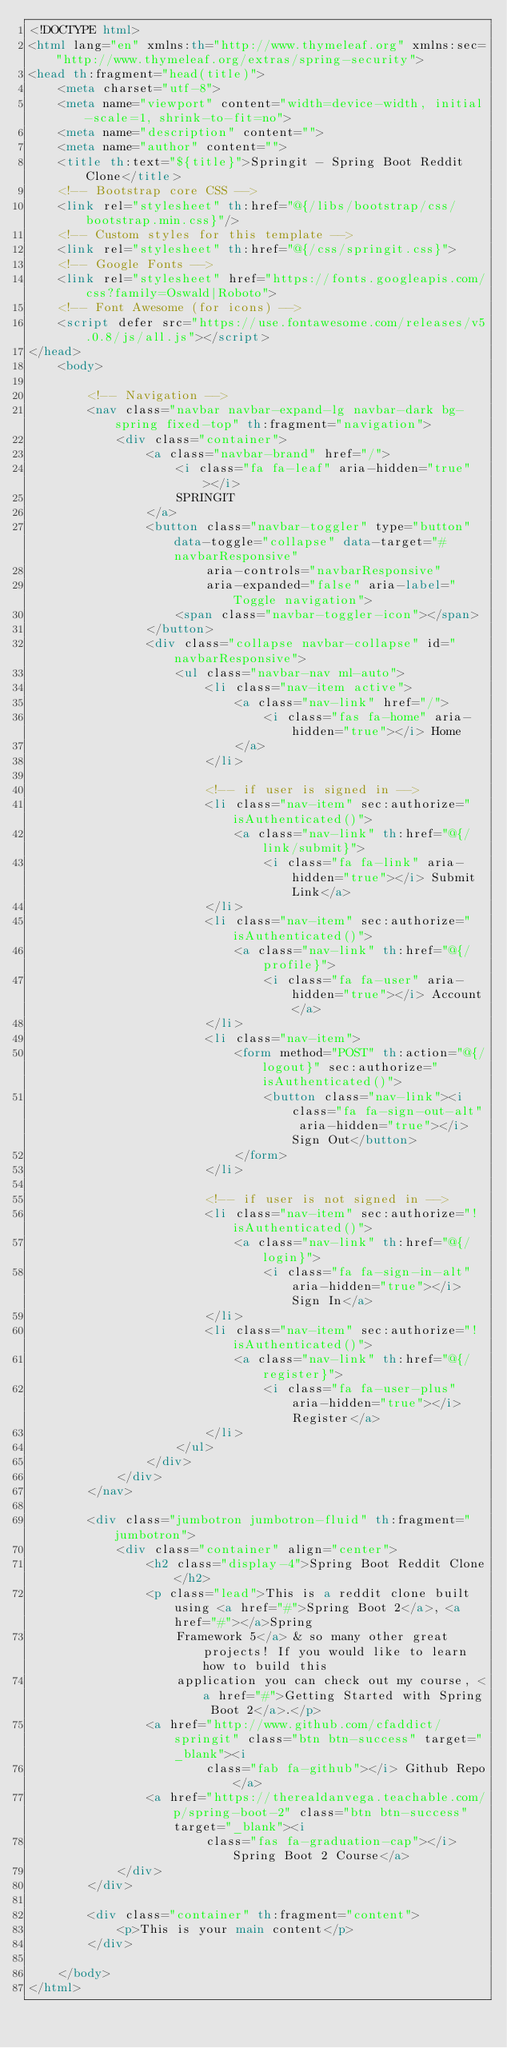Convert code to text. <code><loc_0><loc_0><loc_500><loc_500><_HTML_><!DOCTYPE html>
<html lang="en" xmlns:th="http://www.thymeleaf.org" xmlns:sec="http://www.thymeleaf.org/extras/spring-security">
<head th:fragment="head(title)">
    <meta charset="utf-8">
    <meta name="viewport" content="width=device-width, initial-scale=1, shrink-to-fit=no">
    <meta name="description" content="">
    <meta name="author" content="">
    <title th:text="${title}">Springit - Spring Boot Reddit Clone</title>
    <!-- Bootstrap core CSS -->
    <link rel="stylesheet" th:href="@{/libs/bootstrap/css/bootstrap.min.css}"/>
    <!-- Custom styles for this template -->
    <link rel="stylesheet" th:href="@{/css/springit.css}">
    <!-- Google Fonts -->
    <link rel="stylesheet" href="https://fonts.googleapis.com/css?family=Oswald|Roboto">
    <!-- Font Awesome (for icons) -->
    <script defer src="https://use.fontawesome.com/releases/v5.0.8/js/all.js"></script>
</head>
    <body>

        <!-- Navigation -->
        <nav class="navbar navbar-expand-lg navbar-dark bg-spring fixed-top" th:fragment="navigation">
            <div class="container">
                <a class="navbar-brand" href="/">
                    <i class="fa fa-leaf" aria-hidden="true"></i>
                    SPRINGIT
                </a>
                <button class="navbar-toggler" type="button" data-toggle="collapse" data-target="#navbarResponsive"
                        aria-controls="navbarResponsive"
                        aria-expanded="false" aria-label="Toggle navigation">
                    <span class="navbar-toggler-icon"></span>
                </button>
                <div class="collapse navbar-collapse" id="navbarResponsive">
                    <ul class="navbar-nav ml-auto">
                        <li class="nav-item active">
                            <a class="nav-link" href="/">
                                <i class="fas fa-home" aria-hidden="true"></i> Home
                            </a>
                        </li>

                        <!-- if user is signed in -->
                        <li class="nav-item" sec:authorize="isAuthenticated()">
                            <a class="nav-link" th:href="@{/link/submit}">
                                <i class="fa fa-link" aria-hidden="true"></i> Submit Link</a>
                        </li>
                        <li class="nav-item" sec:authorize="isAuthenticated()">
                            <a class="nav-link" th:href="@{/profile}">
                                <i class="fa fa-user" aria-hidden="true"></i> Account</a>
                        </li>
                        <li class="nav-item">
                            <form method="POST" th:action="@{/logout}" sec:authorize="isAuthenticated()">
                                <button class="nav-link"><i class="fa fa-sign-out-alt" aria-hidden="true"></i> Sign Out</button>
                            </form>
                        </li>

                        <!-- if user is not signed in -->
                        <li class="nav-item" sec:authorize="!isAuthenticated()">
                            <a class="nav-link" th:href="@{/login}">
                                <i class="fa fa-sign-in-alt" aria-hidden="true"></i> Sign In</a>
                        </li>
                        <li class="nav-item" sec:authorize="!isAuthenticated()">
                            <a class="nav-link" th:href="@{/register}">
                                <i class="fa fa-user-plus" aria-hidden="true"></i> Register</a>
                        </li>
                    </ul>
                </div>
            </div>
        </nav>

        <div class="jumbotron jumbotron-fluid" th:fragment="jumbotron">
            <div class="container" align="center">
                <h2 class="display-4">Spring Boot Reddit Clone</h2>
                <p class="lead">This is a reddit clone built using <a href="#">Spring Boot 2</a>, <a href="#"></a>Spring
                    Framework 5</a> & so many other great projects! If you would like to learn how to build this
                    application you can check out my course, <a href="#">Getting Started with Spring Boot 2</a>.</p>
                <a href="http://www.github.com/cfaddict/springit" class="btn btn-success" target="_blank"><i
                        class="fab fa-github"></i> Github Repo</a>
                <a href="https://therealdanvega.teachable.com/p/spring-boot-2" class="btn btn-success" target="_blank"><i
                        class="fas fa-graduation-cap"></i> Spring Boot 2 Course</a>
            </div>
        </div>

        <div class="container" th:fragment="content">
            <p>This is your main content</p>
        </div>

    </body>
</html></code> 